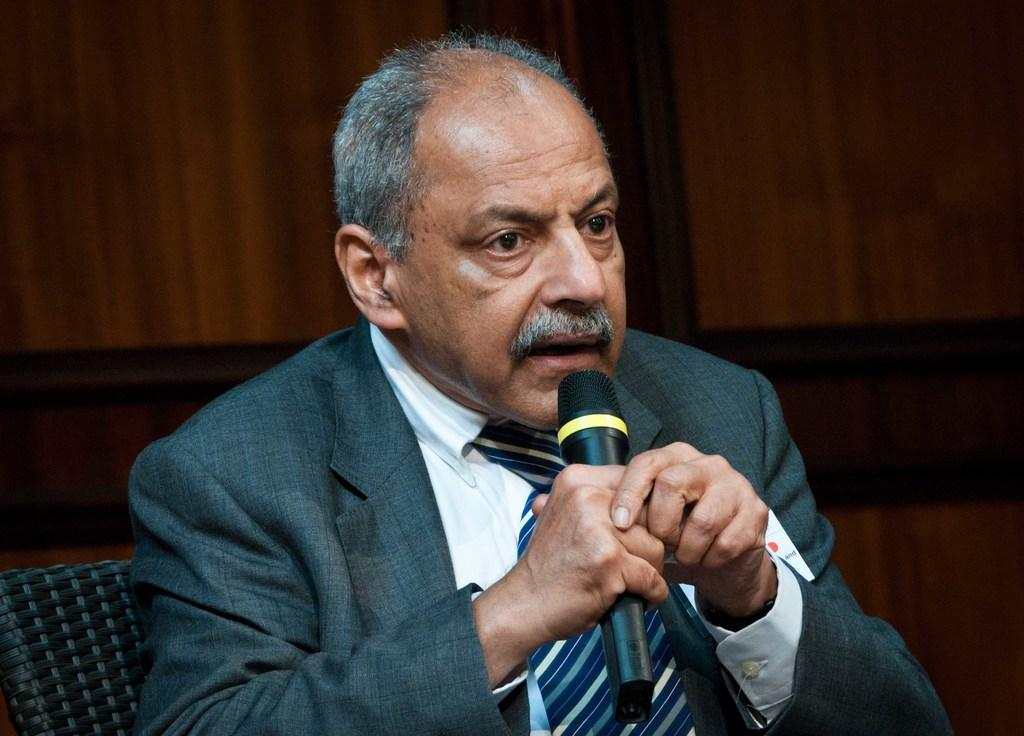What is the person in the image doing? The person is sitting on a chair and holding a microphone. Can you describe the person's position in the image? The person is sitting on a chair, which suggests they might be in a seated or relaxed position. What object is the person holding in the image? The person is holding a microphone, which might indicate that they are speaking or performing. What type of yoke is the person wearing in the image? There is no yoke present in the image; the person is holding a microphone while sitting on a chair. 